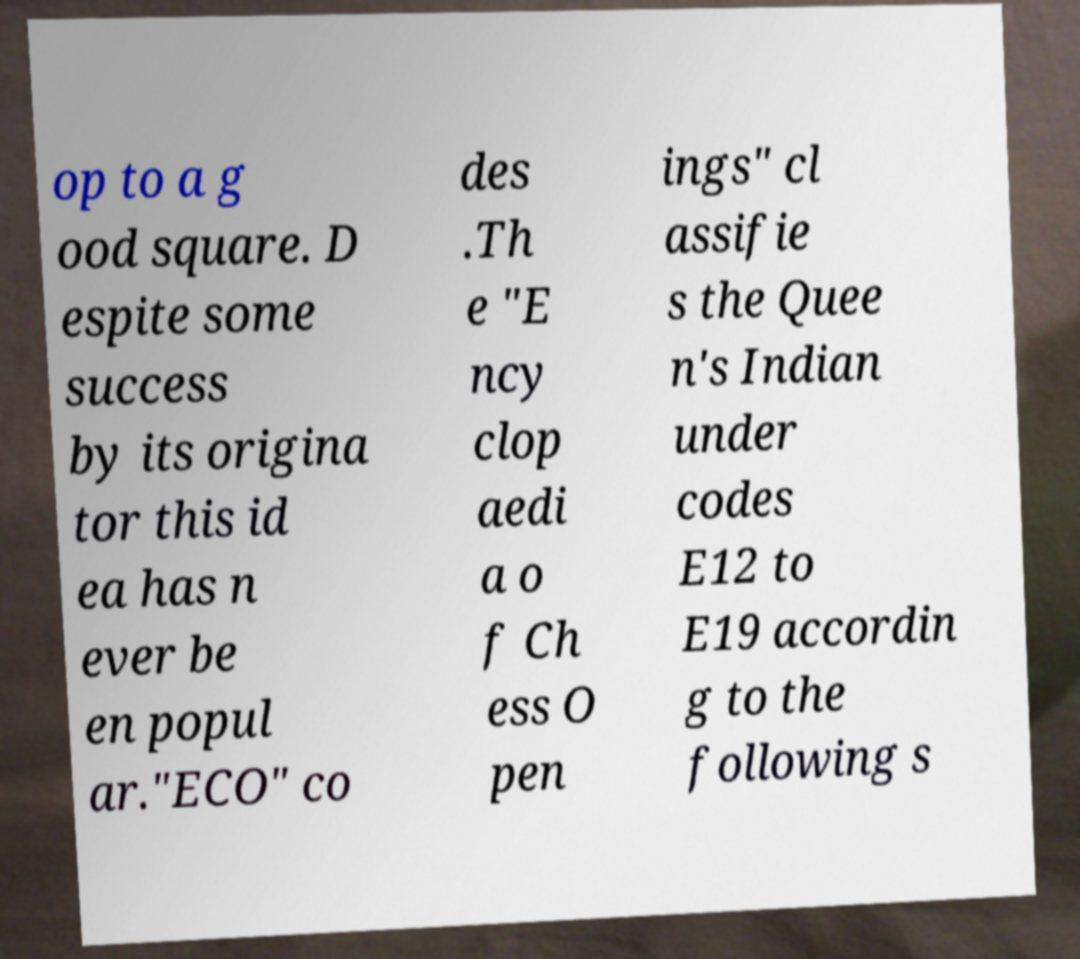I need the written content from this picture converted into text. Can you do that? op to a g ood square. D espite some success by its origina tor this id ea has n ever be en popul ar."ECO" co des .Th e "E ncy clop aedi a o f Ch ess O pen ings" cl assifie s the Quee n's Indian under codes E12 to E19 accordin g to the following s 